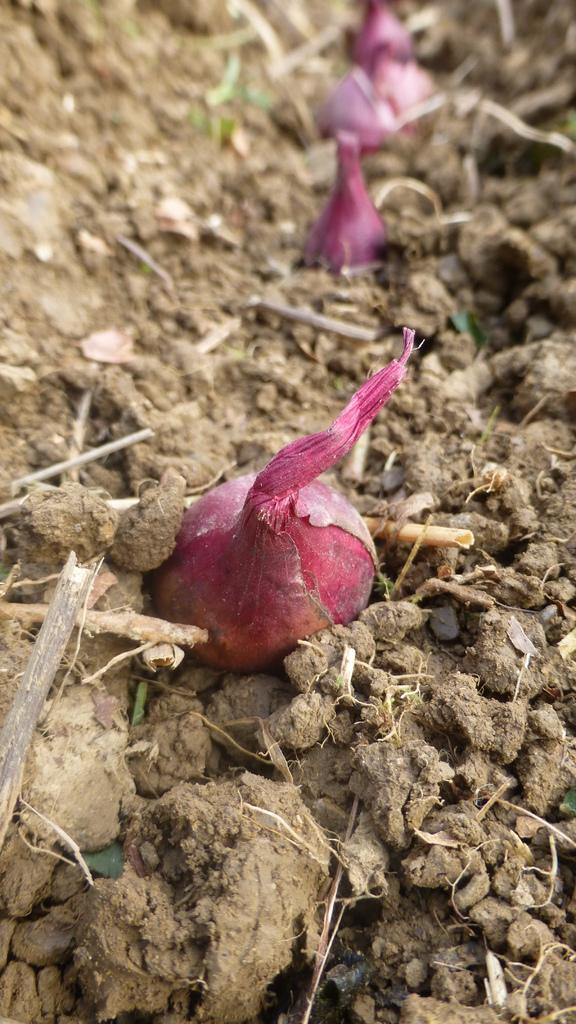What type of vegetable is present in the image? There are onions in the image. Where are the onions located in the image? The onions are on the ground. What type of operation is being performed on the lettuce in the image? There is no lettuce present in the image, and no operation is being performed. 